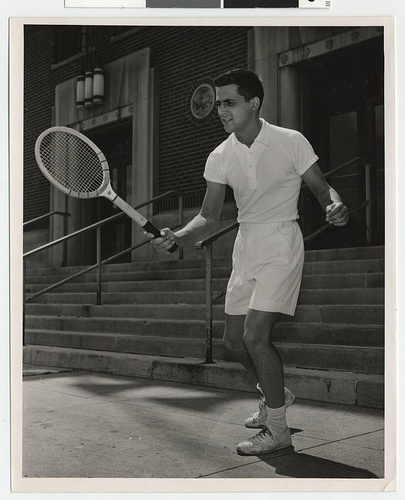Describe the objects in this image and their specific colors. I can see people in white, darkgray, black, and gray tones, tennis racket in white, gray, black, and darkgray tones, and clock in white, black, and gray tones in this image. 